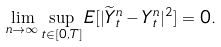Convert formula to latex. <formula><loc_0><loc_0><loc_500><loc_500>\lim _ { n \rightarrow \infty } \sup _ { t \in [ 0 , T ] } E [ | \widetilde { Y } ^ { n } _ { t } - Y ^ { n } _ { t } | ^ { 2 } ] = 0 .</formula> 